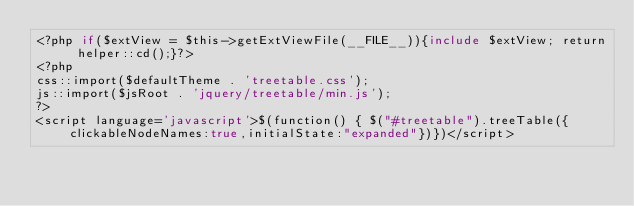Convert code to text. <code><loc_0><loc_0><loc_500><loc_500><_PHP_><?php if($extView = $this->getExtViewFile(__FILE__)){include $extView; return helper::cd();}?>
<?php 
css::import($defaultTheme . 'treetable.css');
js::import($jsRoot . 'jquery/treetable/min.js');
?>
<script language='javascript'>$(function() { $("#treetable").treeTable({clickableNodeNames:true,initialState:"expanded"})})</script>
</code> 